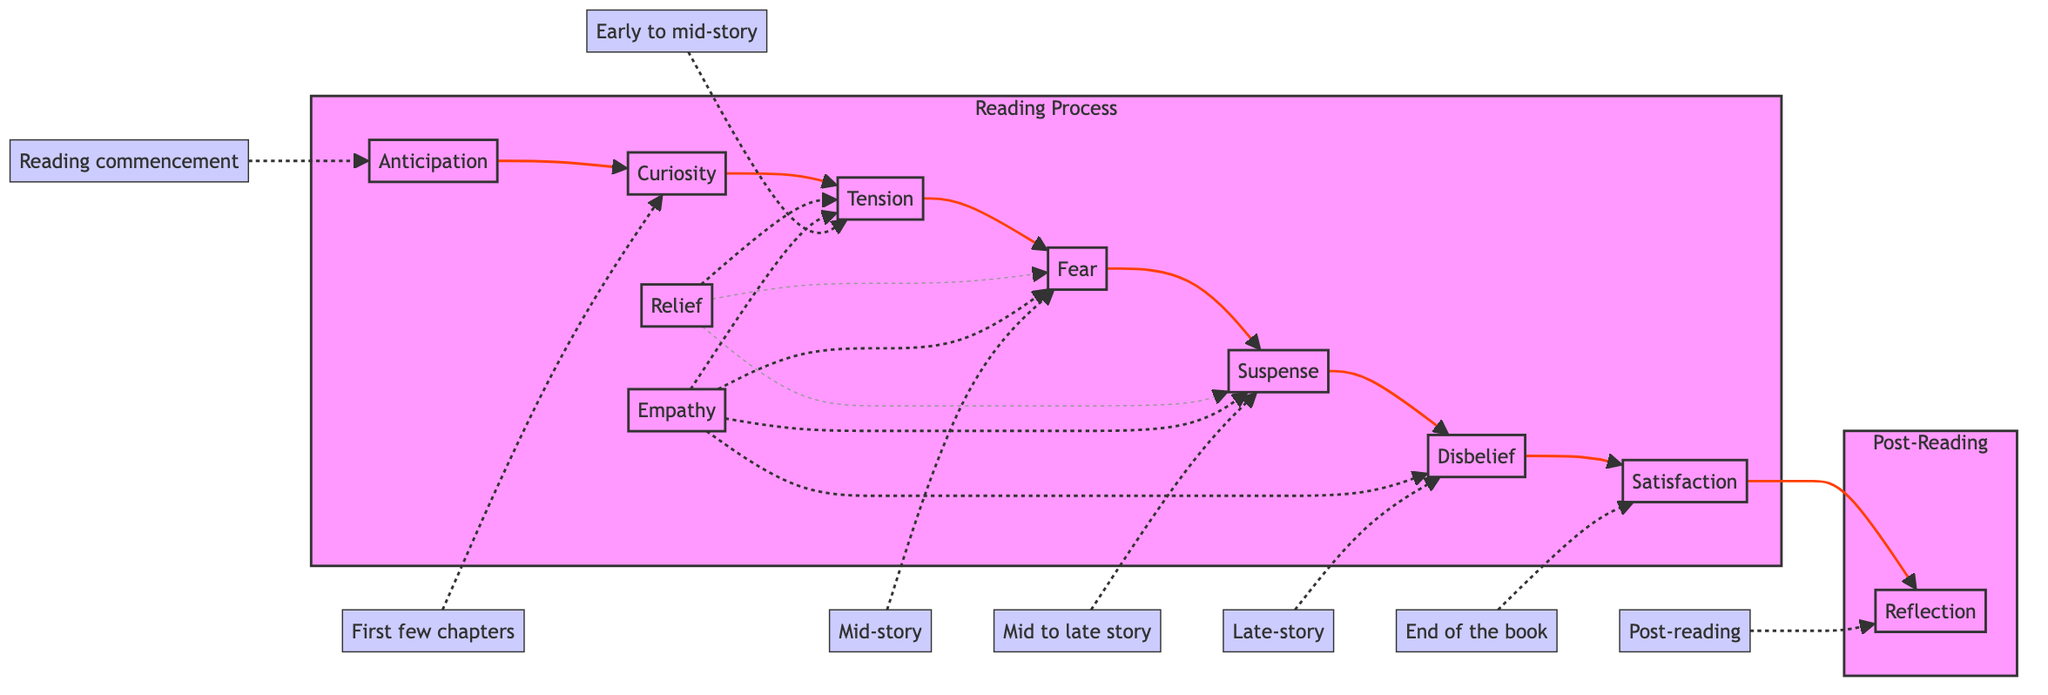What is the first emotional response depicted in the diagram? The diagram shows "Anticipation" as the first emotional response, which is connected to the reading commencement.
Answer: Anticipation How many emotional responses are there in total? By counting the nodes in the 'Reading Process' section, there are ten emotional responses represented.
Answer: Ten Which emotional response follows "Tension"? Following "Tension," the next response is "Fear," connected by a direct arrow indicating the sequence of emotions experienced by the reader.
Answer: Fear How is "Relief" related to the other emotions? "Relief" is presented as a dotted line connection to "Tension," "Fear," and "Suspense," indicating it acts as a temporary response that intersects with these emotions.
Answer: Temporary response At what point do readers typically reflect on their experience? Reflection occurs at the end of the reading process, indicated by a flow from "Satisfaction" to "Reflection" in the Post-Reading subgraph.
Answer: Post-reading After encountering "Disbelief," what is the next emotional response? The diagram shows that after "Disbelief," the next response is "Satisfaction," indicating a progression from surprise to closure.
Answer: Satisfaction Which emotional responses are represented as dotted connections in the flowchart? The dotted connections represent "Relief" and "Empathy," which indicate that these responses are not constant and occur at various points rather than in a linear sequence.
Answer: Relief and Empathy What creates heightened suspense in the reading experience? "Suspense" is heightened by the presence of cliffhangers and plot twists that maintain reader engagement, indicated in the flowchart during the mid to late story.
Answer: Cliffhangers and twists How many timeframes are related to "Fear"? The only timeframe related to "Fear" is labeled "Mid-story," indicating the specific point in the reading process when fear is most prominent.
Answer: One 